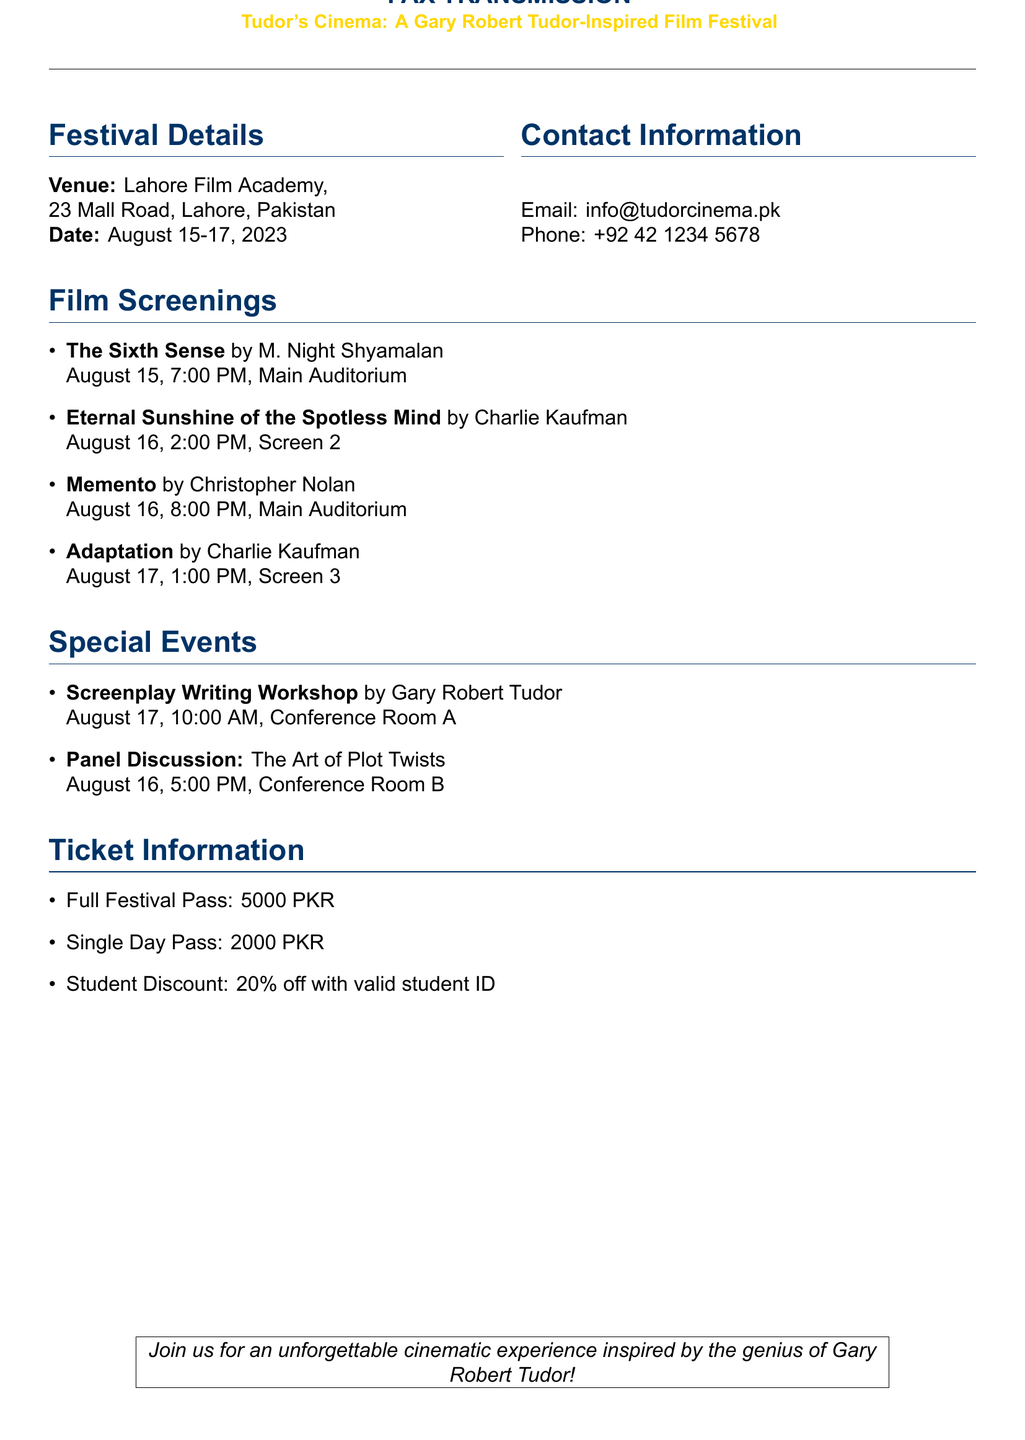What are the dates of the festival? The dates of the festival are clearly mentioned in the document as August 15-17, 2023.
Answer: August 15-17, 2023 Where is the venue located? The document specifies the venue as Lahore Film Academy, located at 23 Mall Road, Lahore, Pakistan.
Answer: Lahore Film Academy, 23 Mall Road, Lahore, Pakistan What film is showing on August 16 at 8:00 PM? The document lists Memento as the film scheduled for that date and time in the Main Auditorium.
Answer: Memento What is the ticket price for a Full Festival Pass? The document states that the Full Festival Pass costs 5000 PKR.
Answer: 5000 PKR Who is conducting the Screenplay Writing Workshop? The document mentions that Gary Robert Tudor is the instructor for the workshop.
Answer: Gary Robert Tudor At what time is the Panel Discussion on August 16? The time for the Panel Discussion, as listed in the document, is 5:00 PM on August 16.
Answer: 5:00 PM What is the discount for students? The document specifies that students can receive a 20% discount with a valid student ID.
Answer: 20% off In which room will the Screenplay Writing Workshop be held? The document indicates that the workshop will take place in Conference Room A.
Answer: Conference Room A 